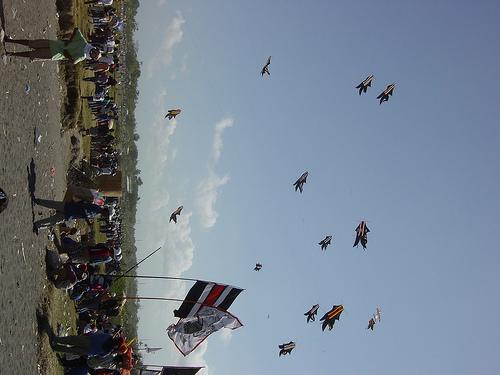How many flags are there?
Be succinct. 2. Is it cold here?
Keep it brief. No. How many kites are on air?
Short answer required. 13. How many people in the shot?
Answer briefly. 100. 